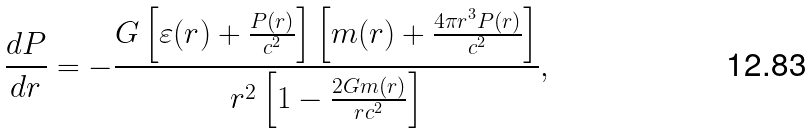Convert formula to latex. <formula><loc_0><loc_0><loc_500><loc_500>\frac { d P } { d r } = - \frac { G \left [ \varepsilon ( r ) + \frac { P ( r ) } { c ^ { 2 } } \right ] \left [ m ( r ) + \frac { 4 \pi r ^ { 3 } P ( r ) } { c ^ { 2 } } \right ] } { r ^ { 2 } \left [ 1 - \frac { 2 G m ( r ) } { r c ^ { 2 } } \right ] } ,</formula> 